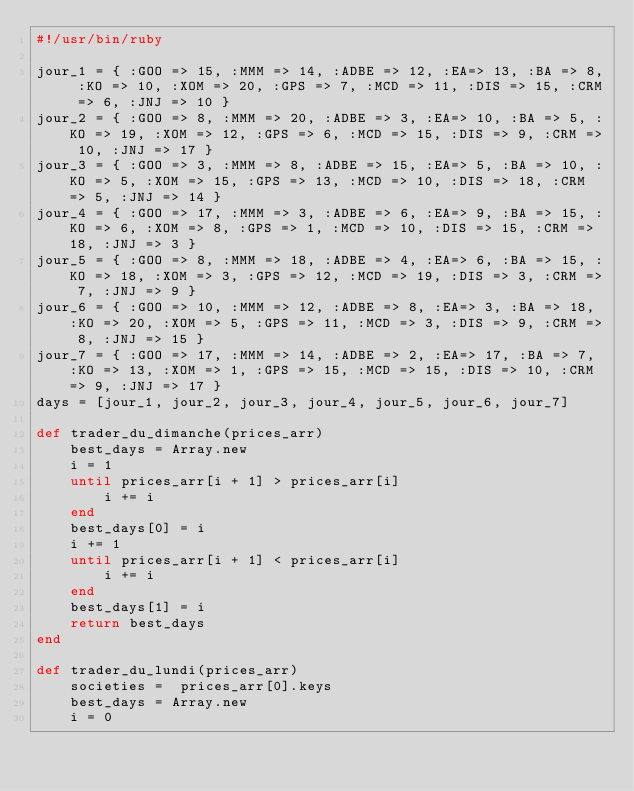Convert code to text. <code><loc_0><loc_0><loc_500><loc_500><_Ruby_>#!/usr/bin/ruby

jour_1 = { :GOO => 15, :MMM => 14, :ADBE => 12, :EA=> 13, :BA => 8, :KO => 10, :XOM => 20, :GPS => 7, :MCD => 11, :DIS => 15, :CRM => 6, :JNJ => 10 }
jour_2 = { :GOO => 8, :MMM => 20, :ADBE => 3, :EA=> 10, :BA => 5, :KO => 19, :XOM => 12, :GPS => 6, :MCD => 15, :DIS => 9, :CRM => 10, :JNJ => 17 }
jour_3 = { :GOO => 3, :MMM => 8, :ADBE => 15, :EA=> 5, :BA => 10, :KO => 5, :XOM => 15, :GPS => 13, :MCD => 10, :DIS => 18, :CRM => 5, :JNJ => 14 }
jour_4 = { :GOO => 17, :MMM => 3, :ADBE => 6, :EA=> 9, :BA => 15, :KO => 6, :XOM => 8, :GPS => 1, :MCD => 10, :DIS => 15, :CRM => 18, :JNJ => 3 }
jour_5 = { :GOO => 8, :MMM => 18, :ADBE => 4, :EA=> 6, :BA => 15, :KO => 18, :XOM => 3, :GPS => 12, :MCD => 19, :DIS => 3, :CRM => 7, :JNJ => 9 }
jour_6 = { :GOO => 10, :MMM => 12, :ADBE => 8, :EA=> 3, :BA => 18, :KO => 20, :XOM => 5, :GPS => 11, :MCD => 3, :DIS => 9, :CRM => 8, :JNJ => 15 }
jour_7 = { :GOO => 17, :MMM => 14, :ADBE => 2, :EA=> 17, :BA => 7, :KO => 13, :XOM => 1, :GPS => 15, :MCD => 15, :DIS => 10, :CRM => 9, :JNJ => 17 }
days = [jour_1, jour_2, jour_3, jour_4, jour_5, jour_6, jour_7]

def trader_du_dimanche(prices_arr)
	best_days = Array.new
	i = 1
	until prices_arr[i + 1] > prices_arr[i]
		i += i
	end
	best_days[0] = i
	i += 1
	until prices_arr[i + 1] < prices_arr[i]
		i += i
	end
	best_days[1] = i
	return best_days
end

def trader_du_lundi(prices_arr)
	societies =  prices_arr[0].keys
	best_days = Array.new
	i = 0</code> 